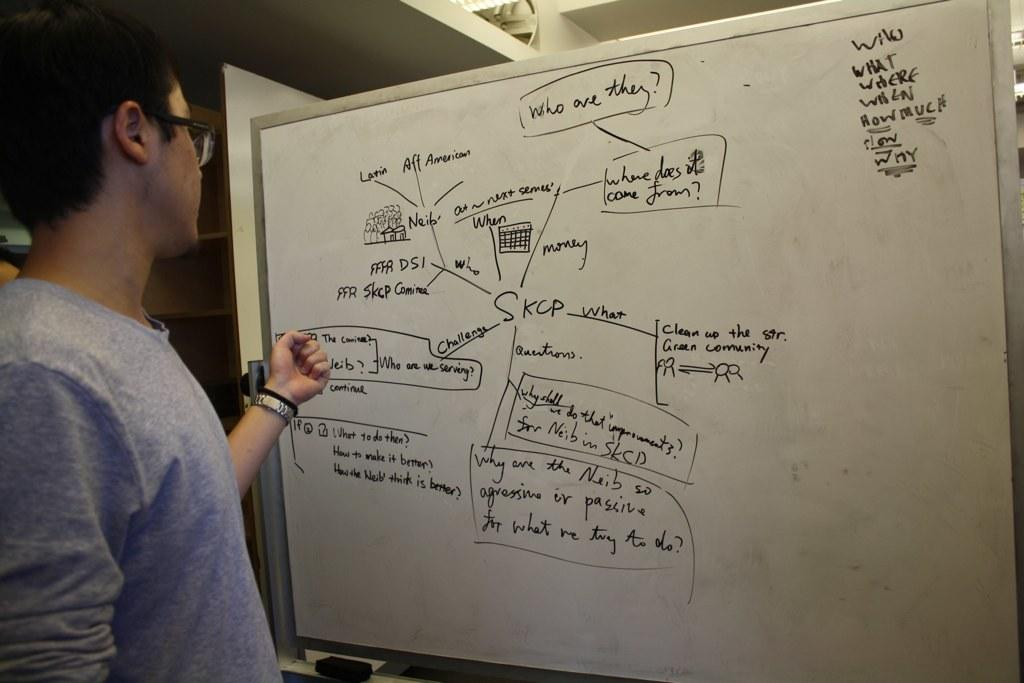<image>
Create a compact narrative representing the image presented. A man writing out a plot on a marker board. 